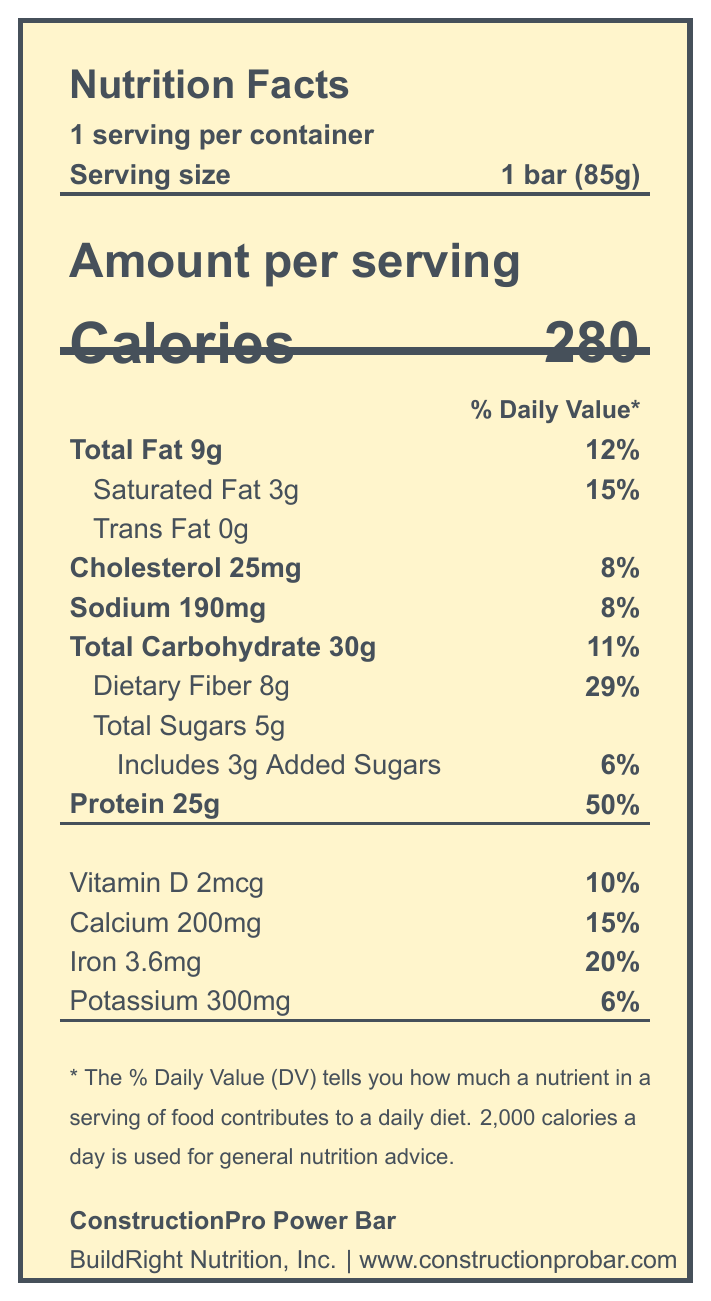what is the serving size of the ConstructionPro Power Bar? The document explicitly states that the serving size is 1 bar (85g).
Answer: 1 bar (85g) how many calories does one ConstructionPro Power Bar contain? The document shows that one serving (1 bar) contains 280 calories.
Answer: 280 how much protein is in one Power Bar? The document lists the protein content as 25g per serving.
Answer: 25g what is the percentage of Daily Value for dietary fiber in the Power Bar? The document shows that the Daily Value percentage for dietary fiber is 29%.
Answer: 29% does the Power Bar contain trans fat? According to the document, the Power Bar contains 0g of trans fat.
Answer: No what is the total carbohydrate content in the Power Bar? The document states that the total carbohydrate content is 30g per serving.
Answer: 30g which ingredient is not present in the Power Bar? 
  A. Almonds
  B. Brown rice syrup
  C. High fructose corn syrup
  D. Whey protein isolate The document lists almonds, brown rice syrup, and whey protein isolate as ingredients but does not mention high fructose corn syrup.
Answer: C. High fructose corn syrup what nutritional claim is associated with protein content in the Power Bar? 
  1. Supports bone health with added calcium
  2. 25g of high-quality protein for muscle recovery
  3. No artificial colors or preservatives
  4. Quick and convenient energy for busy contractors The document makes a specific marketing claim that the bar contains 25g of high-quality protein for muscle recovery.
Answer: 2. 25g of high-quality protein for muscle recovery is it safe for someone with a peanut allergy to eat this Power Bar? The document clearly states that the Power Bar contains peanuts.
Answer: No summarize the main nutritional features of the ConstructionPro Power Bar. The document provides detailed nutritional information along with the ingredients, allergen information, marketing claims, and storage instructions, highlighting its high protein and fiber content aimed at busy contractors.
Answer: The ConstructionPro Power Bar is a high-protein meal replacement designed for busy contractors. It contains 280 calories, 25g of protein (50% Daily Value), and 8g of dietary fiber (29% Daily Value). It also includes essential vitamins and minerals like Vitamin D, calcium, iron, and potassium. The bar is made with natural ingredients and claims to provide quick and convenient energy, support bone health, and avoid artificial colors or preservatives. how many grams of added sugars are in one Power Bar? The document indicates that there are 3g of added sugars per serving.
Answer: 3g what percentage of the Daily Value for sodium does the Power Bar provide? The document lists the sodium content as 190mg, which is 8% of the Daily Value.
Answer: 8% how should the Power Bar be stored? The document provides specific storage instructions which are to keep the bar in a cool, dry place and consume it within 14 days of opening.
Answer: Store in a cool, dry place. Consume within 14 days of opening. is the protein content more than 40% of the Daily Value? The document shows that the protein content is 50% of the Daily Value.
Answer: Yes who is the manufacturer of the ConstructionPro Power Bar? The document states that BuildRight Nutrition, Inc. is the manufacturer.
Answer: BuildRight Nutrition, Inc. where can more information be obtained about the ConstructionPro Power Bar? The document provides a website and a phone number for more information.
Answer: www.constructionprobar.com, 1-800-555-BUILD what is the primary purpose of the high-protein content in the Power Bar? According to the marketing claims in the document, the 25g of high-quality protein is intended for muscle recovery.
Answer: Muscle recovery how much cholesterol does the Power Bar contain? The document lists the cholesterol content as 25mg per serving.
Answer: 25mg how much iron is in the Power Bar? The document shows that the Power Bar contains 3.6mg of iron.
Answer: 3.6mg does the Power Bar contain Vitamin C? The document does not provide any details about Vitamin C content.
Answer: Not enough information 